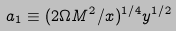<formula> <loc_0><loc_0><loc_500><loc_500>a _ { 1 } \equiv ( 2 \Omega M ^ { 2 } / x ) ^ { 1 / 4 } y ^ { 1 / 2 }</formula> 